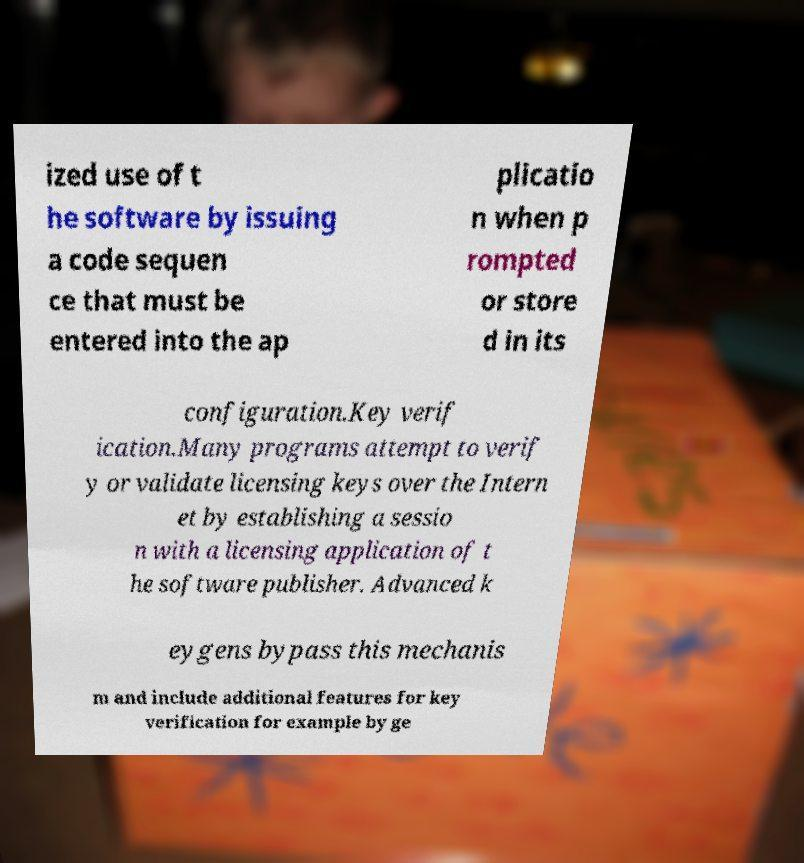Can you accurately transcribe the text from the provided image for me? ized use of t he software by issuing a code sequen ce that must be entered into the ap plicatio n when p rompted or store d in its configuration.Key verif ication.Many programs attempt to verif y or validate licensing keys over the Intern et by establishing a sessio n with a licensing application of t he software publisher. Advanced k eygens bypass this mechanis m and include additional features for key verification for example by ge 